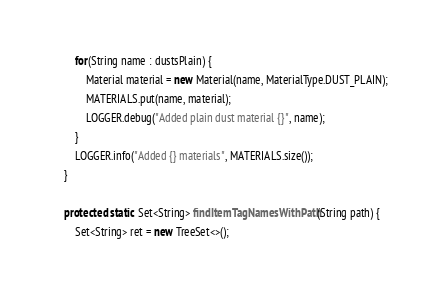Convert code to text. <code><loc_0><loc_0><loc_500><loc_500><_Java_>		for(String name : dustsPlain) {
			Material material = new Material(name, MaterialType.DUST_PLAIN);
			MATERIALS.put(name, material);
			LOGGER.debug("Added plain dust material {}", name);
		}
		LOGGER.info("Added {} materials", MATERIALS.size());
	}

	protected static Set<String> findItemTagNamesWithPath(String path) {
		Set<String> ret = new TreeSet<>();</code> 